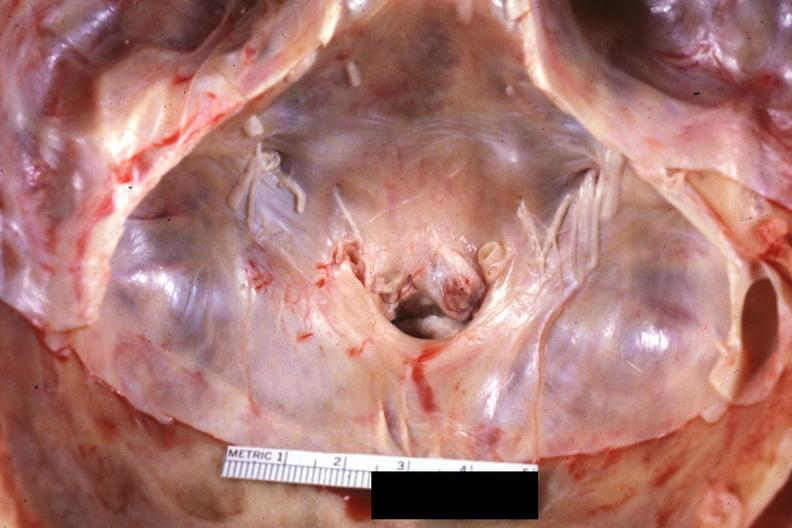s situs inversus present?
Answer the question using a single word or phrase. No 